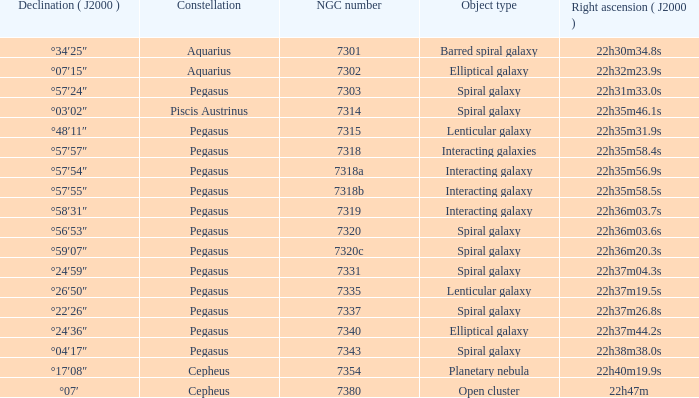What is the right ascension of Pegasus with a 7343 NGC? 22h38m38.0s. 